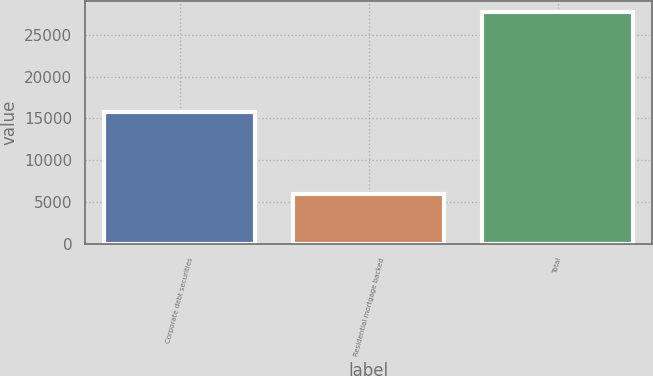<chart> <loc_0><loc_0><loc_500><loc_500><bar_chart><fcel>Corporate debt securities<fcel>Residential mortgage backed<fcel>Total<nl><fcel>15750<fcel>5933<fcel>27752<nl></chart> 